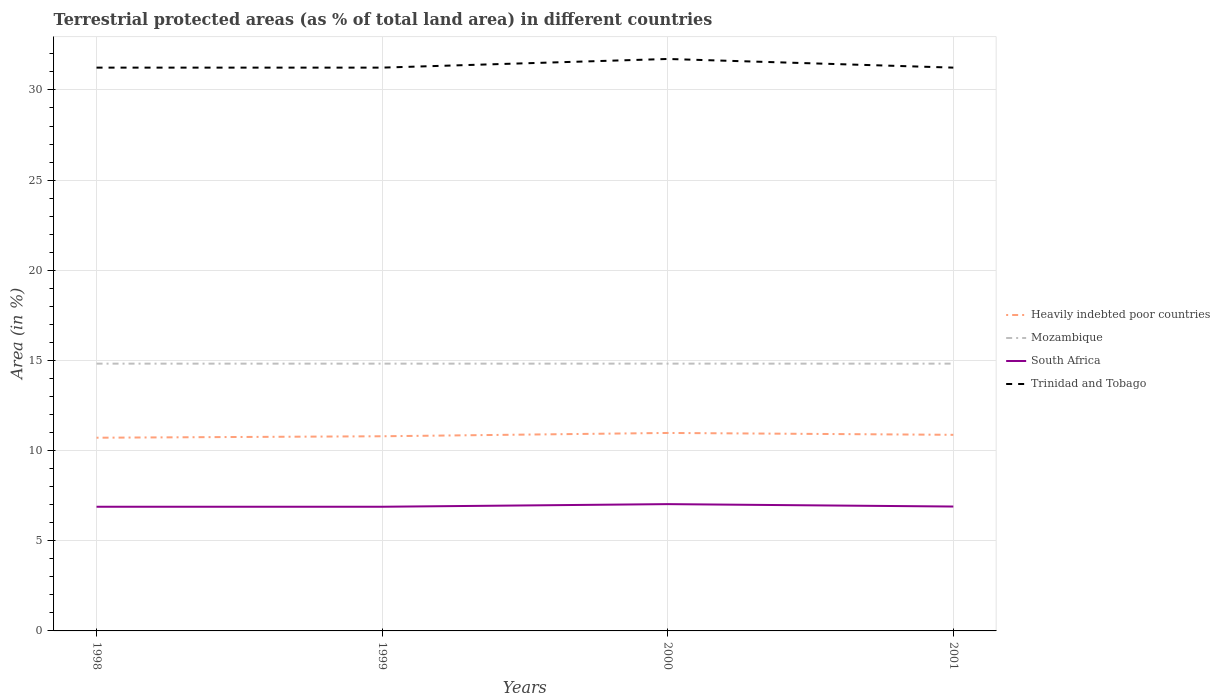How many different coloured lines are there?
Make the answer very short. 4. Across all years, what is the maximum percentage of terrestrial protected land in Mozambique?
Keep it short and to the point. 14.82. In which year was the percentage of terrestrial protected land in Heavily indebted poor countries maximum?
Give a very brief answer. 1998. What is the total percentage of terrestrial protected land in Mozambique in the graph?
Your answer should be very brief. -0. What is the difference between the highest and the second highest percentage of terrestrial protected land in Mozambique?
Offer a terse response. 0. What is the difference between the highest and the lowest percentage of terrestrial protected land in South Africa?
Provide a succinct answer. 1. How many lines are there?
Keep it short and to the point. 4. Are the values on the major ticks of Y-axis written in scientific E-notation?
Provide a succinct answer. No. Does the graph contain grids?
Your answer should be compact. Yes. How many legend labels are there?
Offer a terse response. 4. What is the title of the graph?
Ensure brevity in your answer.  Terrestrial protected areas (as % of total land area) in different countries. Does "Mauritania" appear as one of the legend labels in the graph?
Offer a terse response. No. What is the label or title of the Y-axis?
Your response must be concise. Area (in %). What is the Area (in %) of Heavily indebted poor countries in 1998?
Make the answer very short. 10.71. What is the Area (in %) in Mozambique in 1998?
Keep it short and to the point. 14.82. What is the Area (in %) in South Africa in 1998?
Keep it short and to the point. 6.89. What is the Area (in %) of Trinidad and Tobago in 1998?
Give a very brief answer. 31.24. What is the Area (in %) of Heavily indebted poor countries in 1999?
Provide a short and direct response. 10.8. What is the Area (in %) of Mozambique in 1999?
Make the answer very short. 14.82. What is the Area (in %) in South Africa in 1999?
Provide a succinct answer. 6.89. What is the Area (in %) in Trinidad and Tobago in 1999?
Give a very brief answer. 31.24. What is the Area (in %) of Heavily indebted poor countries in 2000?
Provide a short and direct response. 10.98. What is the Area (in %) of Mozambique in 2000?
Ensure brevity in your answer.  14.82. What is the Area (in %) in South Africa in 2000?
Your answer should be compact. 7.03. What is the Area (in %) of Trinidad and Tobago in 2000?
Make the answer very short. 31.72. What is the Area (in %) of Heavily indebted poor countries in 2001?
Provide a short and direct response. 10.87. What is the Area (in %) in Mozambique in 2001?
Offer a very short reply. 14.82. What is the Area (in %) in South Africa in 2001?
Your answer should be very brief. 6.9. What is the Area (in %) in Trinidad and Tobago in 2001?
Ensure brevity in your answer.  31.24. Across all years, what is the maximum Area (in %) of Heavily indebted poor countries?
Ensure brevity in your answer.  10.98. Across all years, what is the maximum Area (in %) in Mozambique?
Provide a short and direct response. 14.82. Across all years, what is the maximum Area (in %) of South Africa?
Offer a terse response. 7.03. Across all years, what is the maximum Area (in %) in Trinidad and Tobago?
Provide a succinct answer. 31.72. Across all years, what is the minimum Area (in %) in Heavily indebted poor countries?
Give a very brief answer. 10.71. Across all years, what is the minimum Area (in %) in Mozambique?
Offer a terse response. 14.82. Across all years, what is the minimum Area (in %) in South Africa?
Make the answer very short. 6.89. Across all years, what is the minimum Area (in %) of Trinidad and Tobago?
Keep it short and to the point. 31.24. What is the total Area (in %) of Heavily indebted poor countries in the graph?
Keep it short and to the point. 43.36. What is the total Area (in %) of Mozambique in the graph?
Provide a short and direct response. 59.29. What is the total Area (in %) of South Africa in the graph?
Your response must be concise. 27.7. What is the total Area (in %) of Trinidad and Tobago in the graph?
Keep it short and to the point. 125.43. What is the difference between the Area (in %) in Heavily indebted poor countries in 1998 and that in 1999?
Your answer should be compact. -0.08. What is the difference between the Area (in %) of Mozambique in 1998 and that in 1999?
Provide a short and direct response. 0. What is the difference between the Area (in %) of Trinidad and Tobago in 1998 and that in 1999?
Ensure brevity in your answer.  0. What is the difference between the Area (in %) of Heavily indebted poor countries in 1998 and that in 2000?
Your answer should be very brief. -0.26. What is the difference between the Area (in %) in Mozambique in 1998 and that in 2000?
Offer a very short reply. -0. What is the difference between the Area (in %) in South Africa in 1998 and that in 2000?
Your answer should be compact. -0.15. What is the difference between the Area (in %) in Trinidad and Tobago in 1998 and that in 2000?
Make the answer very short. -0.48. What is the difference between the Area (in %) in Heavily indebted poor countries in 1998 and that in 2001?
Offer a very short reply. -0.16. What is the difference between the Area (in %) of South Africa in 1998 and that in 2001?
Keep it short and to the point. -0.01. What is the difference between the Area (in %) of Trinidad and Tobago in 1998 and that in 2001?
Your answer should be very brief. 0. What is the difference between the Area (in %) of Heavily indebted poor countries in 1999 and that in 2000?
Keep it short and to the point. -0.18. What is the difference between the Area (in %) of Mozambique in 1999 and that in 2000?
Give a very brief answer. -0. What is the difference between the Area (in %) in South Africa in 1999 and that in 2000?
Provide a succinct answer. -0.15. What is the difference between the Area (in %) in Trinidad and Tobago in 1999 and that in 2000?
Provide a short and direct response. -0.48. What is the difference between the Area (in %) of Heavily indebted poor countries in 1999 and that in 2001?
Offer a very short reply. -0.08. What is the difference between the Area (in %) in South Africa in 1999 and that in 2001?
Make the answer very short. -0.01. What is the difference between the Area (in %) of Trinidad and Tobago in 1999 and that in 2001?
Your answer should be compact. 0. What is the difference between the Area (in %) of Heavily indebted poor countries in 2000 and that in 2001?
Your answer should be compact. 0.1. What is the difference between the Area (in %) in Mozambique in 2000 and that in 2001?
Ensure brevity in your answer.  0. What is the difference between the Area (in %) in South Africa in 2000 and that in 2001?
Offer a terse response. 0.13. What is the difference between the Area (in %) in Trinidad and Tobago in 2000 and that in 2001?
Give a very brief answer. 0.48. What is the difference between the Area (in %) in Heavily indebted poor countries in 1998 and the Area (in %) in Mozambique in 1999?
Keep it short and to the point. -4.11. What is the difference between the Area (in %) of Heavily indebted poor countries in 1998 and the Area (in %) of South Africa in 1999?
Provide a succinct answer. 3.83. What is the difference between the Area (in %) of Heavily indebted poor countries in 1998 and the Area (in %) of Trinidad and Tobago in 1999?
Make the answer very short. -20.52. What is the difference between the Area (in %) of Mozambique in 1998 and the Area (in %) of South Africa in 1999?
Ensure brevity in your answer.  7.94. What is the difference between the Area (in %) in Mozambique in 1998 and the Area (in %) in Trinidad and Tobago in 1999?
Give a very brief answer. -16.42. What is the difference between the Area (in %) of South Africa in 1998 and the Area (in %) of Trinidad and Tobago in 1999?
Ensure brevity in your answer.  -24.35. What is the difference between the Area (in %) in Heavily indebted poor countries in 1998 and the Area (in %) in Mozambique in 2000?
Offer a very short reply. -4.11. What is the difference between the Area (in %) in Heavily indebted poor countries in 1998 and the Area (in %) in South Africa in 2000?
Offer a terse response. 3.68. What is the difference between the Area (in %) of Heavily indebted poor countries in 1998 and the Area (in %) of Trinidad and Tobago in 2000?
Offer a terse response. -21. What is the difference between the Area (in %) of Mozambique in 1998 and the Area (in %) of South Africa in 2000?
Offer a very short reply. 7.79. What is the difference between the Area (in %) of Mozambique in 1998 and the Area (in %) of Trinidad and Tobago in 2000?
Your answer should be compact. -16.9. What is the difference between the Area (in %) in South Africa in 1998 and the Area (in %) in Trinidad and Tobago in 2000?
Give a very brief answer. -24.83. What is the difference between the Area (in %) of Heavily indebted poor countries in 1998 and the Area (in %) of Mozambique in 2001?
Make the answer very short. -4.11. What is the difference between the Area (in %) in Heavily indebted poor countries in 1998 and the Area (in %) in South Africa in 2001?
Provide a succinct answer. 3.82. What is the difference between the Area (in %) in Heavily indebted poor countries in 1998 and the Area (in %) in Trinidad and Tobago in 2001?
Offer a very short reply. -20.52. What is the difference between the Area (in %) of Mozambique in 1998 and the Area (in %) of South Africa in 2001?
Offer a terse response. 7.92. What is the difference between the Area (in %) of Mozambique in 1998 and the Area (in %) of Trinidad and Tobago in 2001?
Your response must be concise. -16.42. What is the difference between the Area (in %) of South Africa in 1998 and the Area (in %) of Trinidad and Tobago in 2001?
Offer a terse response. -24.35. What is the difference between the Area (in %) in Heavily indebted poor countries in 1999 and the Area (in %) in Mozambique in 2000?
Provide a succinct answer. -4.03. What is the difference between the Area (in %) of Heavily indebted poor countries in 1999 and the Area (in %) of South Africa in 2000?
Ensure brevity in your answer.  3.76. What is the difference between the Area (in %) in Heavily indebted poor countries in 1999 and the Area (in %) in Trinidad and Tobago in 2000?
Give a very brief answer. -20.92. What is the difference between the Area (in %) of Mozambique in 1999 and the Area (in %) of South Africa in 2000?
Your answer should be compact. 7.79. What is the difference between the Area (in %) of Mozambique in 1999 and the Area (in %) of Trinidad and Tobago in 2000?
Make the answer very short. -16.9. What is the difference between the Area (in %) of South Africa in 1999 and the Area (in %) of Trinidad and Tobago in 2000?
Provide a succinct answer. -24.83. What is the difference between the Area (in %) in Heavily indebted poor countries in 1999 and the Area (in %) in Mozambique in 2001?
Give a very brief answer. -4.03. What is the difference between the Area (in %) in Heavily indebted poor countries in 1999 and the Area (in %) in South Africa in 2001?
Keep it short and to the point. 3.9. What is the difference between the Area (in %) in Heavily indebted poor countries in 1999 and the Area (in %) in Trinidad and Tobago in 2001?
Your answer should be compact. -20.44. What is the difference between the Area (in %) in Mozambique in 1999 and the Area (in %) in South Africa in 2001?
Offer a very short reply. 7.92. What is the difference between the Area (in %) of Mozambique in 1999 and the Area (in %) of Trinidad and Tobago in 2001?
Give a very brief answer. -16.42. What is the difference between the Area (in %) in South Africa in 1999 and the Area (in %) in Trinidad and Tobago in 2001?
Your response must be concise. -24.35. What is the difference between the Area (in %) of Heavily indebted poor countries in 2000 and the Area (in %) of Mozambique in 2001?
Make the answer very short. -3.84. What is the difference between the Area (in %) in Heavily indebted poor countries in 2000 and the Area (in %) in South Africa in 2001?
Make the answer very short. 4.08. What is the difference between the Area (in %) of Heavily indebted poor countries in 2000 and the Area (in %) of Trinidad and Tobago in 2001?
Ensure brevity in your answer.  -20.26. What is the difference between the Area (in %) in Mozambique in 2000 and the Area (in %) in South Africa in 2001?
Ensure brevity in your answer.  7.92. What is the difference between the Area (in %) in Mozambique in 2000 and the Area (in %) in Trinidad and Tobago in 2001?
Give a very brief answer. -16.42. What is the difference between the Area (in %) of South Africa in 2000 and the Area (in %) of Trinidad and Tobago in 2001?
Your response must be concise. -24.21. What is the average Area (in %) in Heavily indebted poor countries per year?
Give a very brief answer. 10.84. What is the average Area (in %) in Mozambique per year?
Offer a terse response. 14.82. What is the average Area (in %) in South Africa per year?
Keep it short and to the point. 6.93. What is the average Area (in %) in Trinidad and Tobago per year?
Offer a terse response. 31.36. In the year 1998, what is the difference between the Area (in %) in Heavily indebted poor countries and Area (in %) in Mozambique?
Your answer should be compact. -4.11. In the year 1998, what is the difference between the Area (in %) in Heavily indebted poor countries and Area (in %) in South Africa?
Offer a very short reply. 3.83. In the year 1998, what is the difference between the Area (in %) in Heavily indebted poor countries and Area (in %) in Trinidad and Tobago?
Provide a succinct answer. -20.52. In the year 1998, what is the difference between the Area (in %) in Mozambique and Area (in %) in South Africa?
Offer a very short reply. 7.94. In the year 1998, what is the difference between the Area (in %) in Mozambique and Area (in %) in Trinidad and Tobago?
Provide a short and direct response. -16.42. In the year 1998, what is the difference between the Area (in %) of South Africa and Area (in %) of Trinidad and Tobago?
Provide a short and direct response. -24.35. In the year 1999, what is the difference between the Area (in %) in Heavily indebted poor countries and Area (in %) in Mozambique?
Provide a short and direct response. -4.03. In the year 1999, what is the difference between the Area (in %) of Heavily indebted poor countries and Area (in %) of South Africa?
Give a very brief answer. 3.91. In the year 1999, what is the difference between the Area (in %) of Heavily indebted poor countries and Area (in %) of Trinidad and Tobago?
Provide a short and direct response. -20.44. In the year 1999, what is the difference between the Area (in %) of Mozambique and Area (in %) of South Africa?
Offer a terse response. 7.94. In the year 1999, what is the difference between the Area (in %) of Mozambique and Area (in %) of Trinidad and Tobago?
Offer a terse response. -16.42. In the year 1999, what is the difference between the Area (in %) in South Africa and Area (in %) in Trinidad and Tobago?
Offer a terse response. -24.35. In the year 2000, what is the difference between the Area (in %) in Heavily indebted poor countries and Area (in %) in Mozambique?
Give a very brief answer. -3.84. In the year 2000, what is the difference between the Area (in %) in Heavily indebted poor countries and Area (in %) in South Africa?
Provide a short and direct response. 3.95. In the year 2000, what is the difference between the Area (in %) in Heavily indebted poor countries and Area (in %) in Trinidad and Tobago?
Your response must be concise. -20.74. In the year 2000, what is the difference between the Area (in %) of Mozambique and Area (in %) of South Africa?
Keep it short and to the point. 7.79. In the year 2000, what is the difference between the Area (in %) in Mozambique and Area (in %) in Trinidad and Tobago?
Ensure brevity in your answer.  -16.9. In the year 2000, what is the difference between the Area (in %) of South Africa and Area (in %) of Trinidad and Tobago?
Offer a terse response. -24.69. In the year 2001, what is the difference between the Area (in %) of Heavily indebted poor countries and Area (in %) of Mozambique?
Offer a very short reply. -3.95. In the year 2001, what is the difference between the Area (in %) in Heavily indebted poor countries and Area (in %) in South Africa?
Your answer should be very brief. 3.98. In the year 2001, what is the difference between the Area (in %) of Heavily indebted poor countries and Area (in %) of Trinidad and Tobago?
Offer a very short reply. -20.36. In the year 2001, what is the difference between the Area (in %) of Mozambique and Area (in %) of South Africa?
Your response must be concise. 7.92. In the year 2001, what is the difference between the Area (in %) of Mozambique and Area (in %) of Trinidad and Tobago?
Provide a short and direct response. -16.42. In the year 2001, what is the difference between the Area (in %) in South Africa and Area (in %) in Trinidad and Tobago?
Offer a very short reply. -24.34. What is the ratio of the Area (in %) of Heavily indebted poor countries in 1998 to that in 1999?
Offer a terse response. 0.99. What is the ratio of the Area (in %) of Mozambique in 1998 to that in 1999?
Offer a very short reply. 1. What is the ratio of the Area (in %) of South Africa in 1998 to that in 1999?
Your response must be concise. 1. What is the ratio of the Area (in %) in Heavily indebted poor countries in 1998 to that in 2000?
Your response must be concise. 0.98. What is the ratio of the Area (in %) in Mozambique in 1998 to that in 2000?
Your answer should be compact. 1. What is the ratio of the Area (in %) in South Africa in 1998 to that in 2000?
Offer a very short reply. 0.98. What is the ratio of the Area (in %) of Trinidad and Tobago in 1998 to that in 2000?
Provide a succinct answer. 0.98. What is the ratio of the Area (in %) in Heavily indebted poor countries in 1999 to that in 2000?
Keep it short and to the point. 0.98. What is the ratio of the Area (in %) in Mozambique in 1999 to that in 2000?
Provide a short and direct response. 1. What is the ratio of the Area (in %) of South Africa in 1999 to that in 2000?
Give a very brief answer. 0.98. What is the ratio of the Area (in %) of Trinidad and Tobago in 1999 to that in 2000?
Keep it short and to the point. 0.98. What is the ratio of the Area (in %) of South Africa in 1999 to that in 2001?
Make the answer very short. 1. What is the ratio of the Area (in %) of Heavily indebted poor countries in 2000 to that in 2001?
Provide a short and direct response. 1.01. What is the ratio of the Area (in %) in South Africa in 2000 to that in 2001?
Ensure brevity in your answer.  1.02. What is the ratio of the Area (in %) of Trinidad and Tobago in 2000 to that in 2001?
Make the answer very short. 1.02. What is the difference between the highest and the second highest Area (in %) of Heavily indebted poor countries?
Ensure brevity in your answer.  0.1. What is the difference between the highest and the second highest Area (in %) of Mozambique?
Ensure brevity in your answer.  0. What is the difference between the highest and the second highest Area (in %) of South Africa?
Offer a very short reply. 0.13. What is the difference between the highest and the second highest Area (in %) in Trinidad and Tobago?
Ensure brevity in your answer.  0.48. What is the difference between the highest and the lowest Area (in %) in Heavily indebted poor countries?
Your answer should be very brief. 0.26. What is the difference between the highest and the lowest Area (in %) of Mozambique?
Provide a short and direct response. 0. What is the difference between the highest and the lowest Area (in %) of South Africa?
Provide a short and direct response. 0.15. What is the difference between the highest and the lowest Area (in %) of Trinidad and Tobago?
Keep it short and to the point. 0.48. 